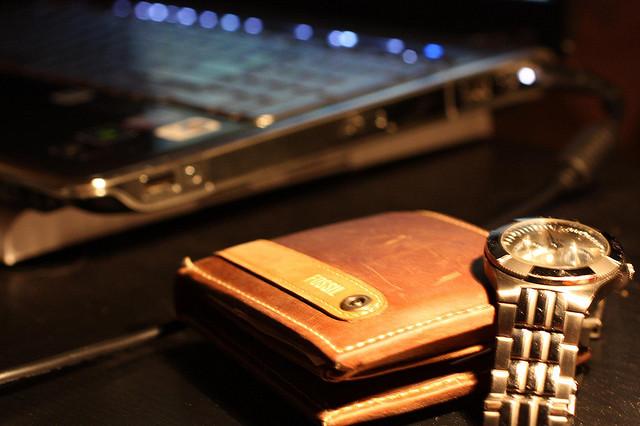What brand is the wallet?
Concise answer only. Fossil. Is the wallet full?
Quick response, please. Yes. Is there  a watch?
Give a very brief answer. Yes. 